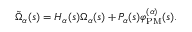Convert formula to latex. <formula><loc_0><loc_0><loc_500><loc_500>\begin{array} { r } { \tilde { \Omega } _ { \alpha } ( s ) = H _ { \alpha } ( s ) \Omega _ { \alpha } ( s ) + P _ { \alpha } ( s ) \varphi _ { P M } ^ { ( \alpha ) } ( s ) . } \end{array}</formula> 